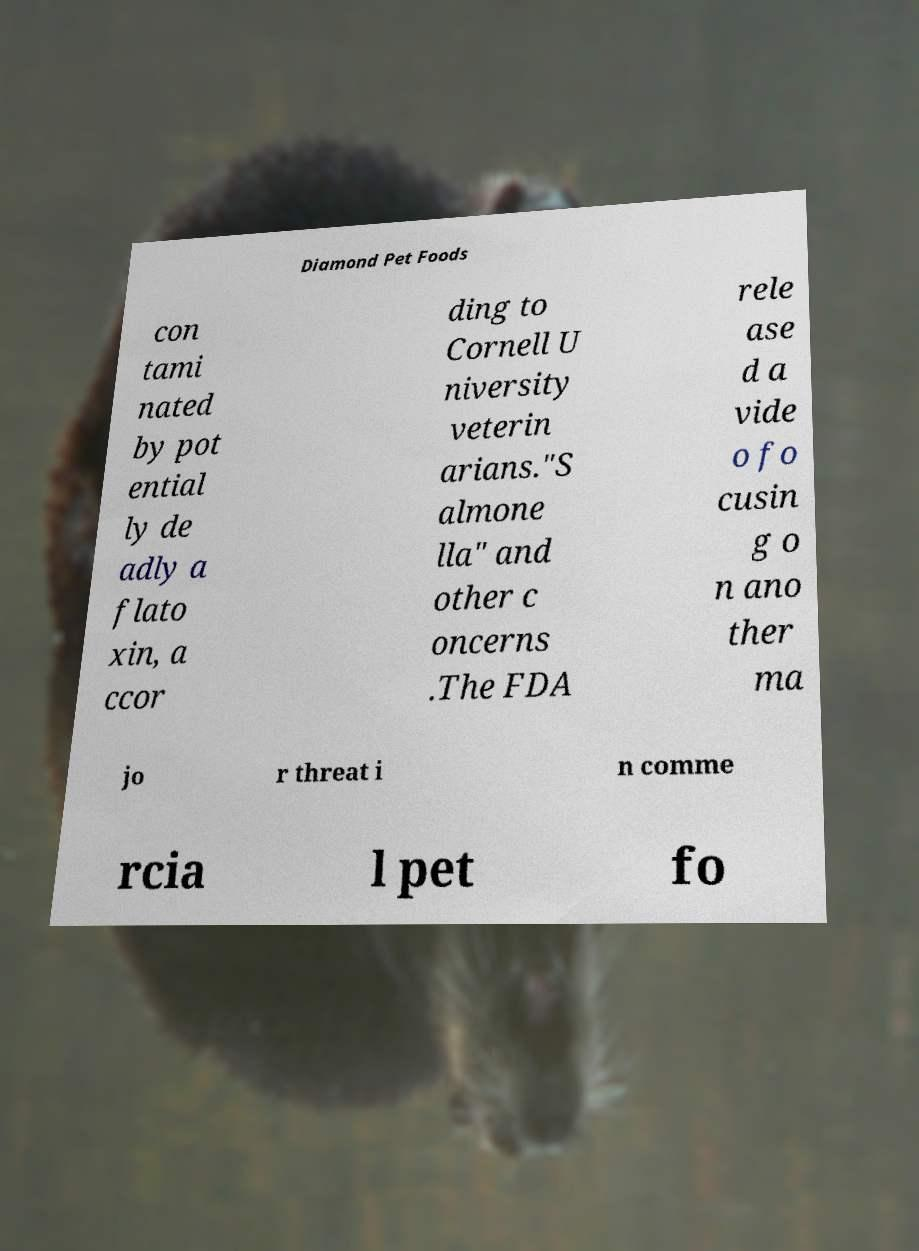What messages or text are displayed in this image? I need them in a readable, typed format. Diamond Pet Foods con tami nated by pot ential ly de adly a flato xin, a ccor ding to Cornell U niversity veterin arians."S almone lla" and other c oncerns .The FDA rele ase d a vide o fo cusin g o n ano ther ma jo r threat i n comme rcia l pet fo 